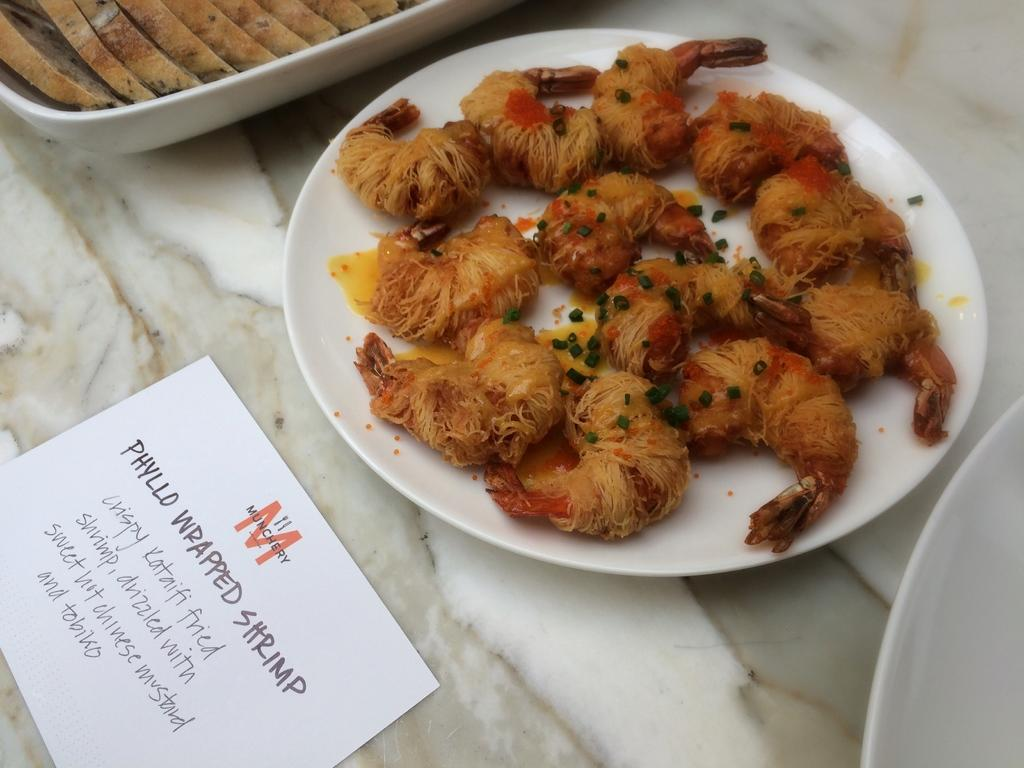What can be seen on the plates in the image? There are food items on plates in the image. What material is the surface on which the card is placed made of? The surface is made of marble in the image. What type of sheet is covering the food items on the plates in the image? There is no sheet covering the food items on the plates in the image. What type of thread is being used to hold the card in place in the image? There is no thread visible in the image; the card is simply placed on the marble surface. 